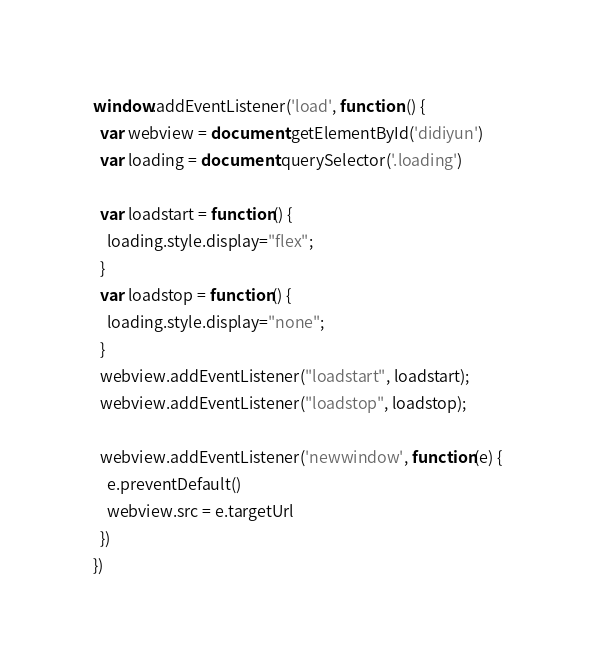Convert code to text. <code><loc_0><loc_0><loc_500><loc_500><_JavaScript_>window.addEventListener('load', function () {
  var webview = document.getElementById('didiyun')
  var loading = document.querySelector('.loading')
  
  var loadstart = function() {
    loading.style.display="flex";
  }
  var loadstop = function() {
    loading.style.display="none";
  }
  webview.addEventListener("loadstart", loadstart);
  webview.addEventListener("loadstop", loadstop);

  webview.addEventListener('newwindow', function(e) {
    e.preventDefault()
    webview.src = e.targetUrl
  })
})
</code> 